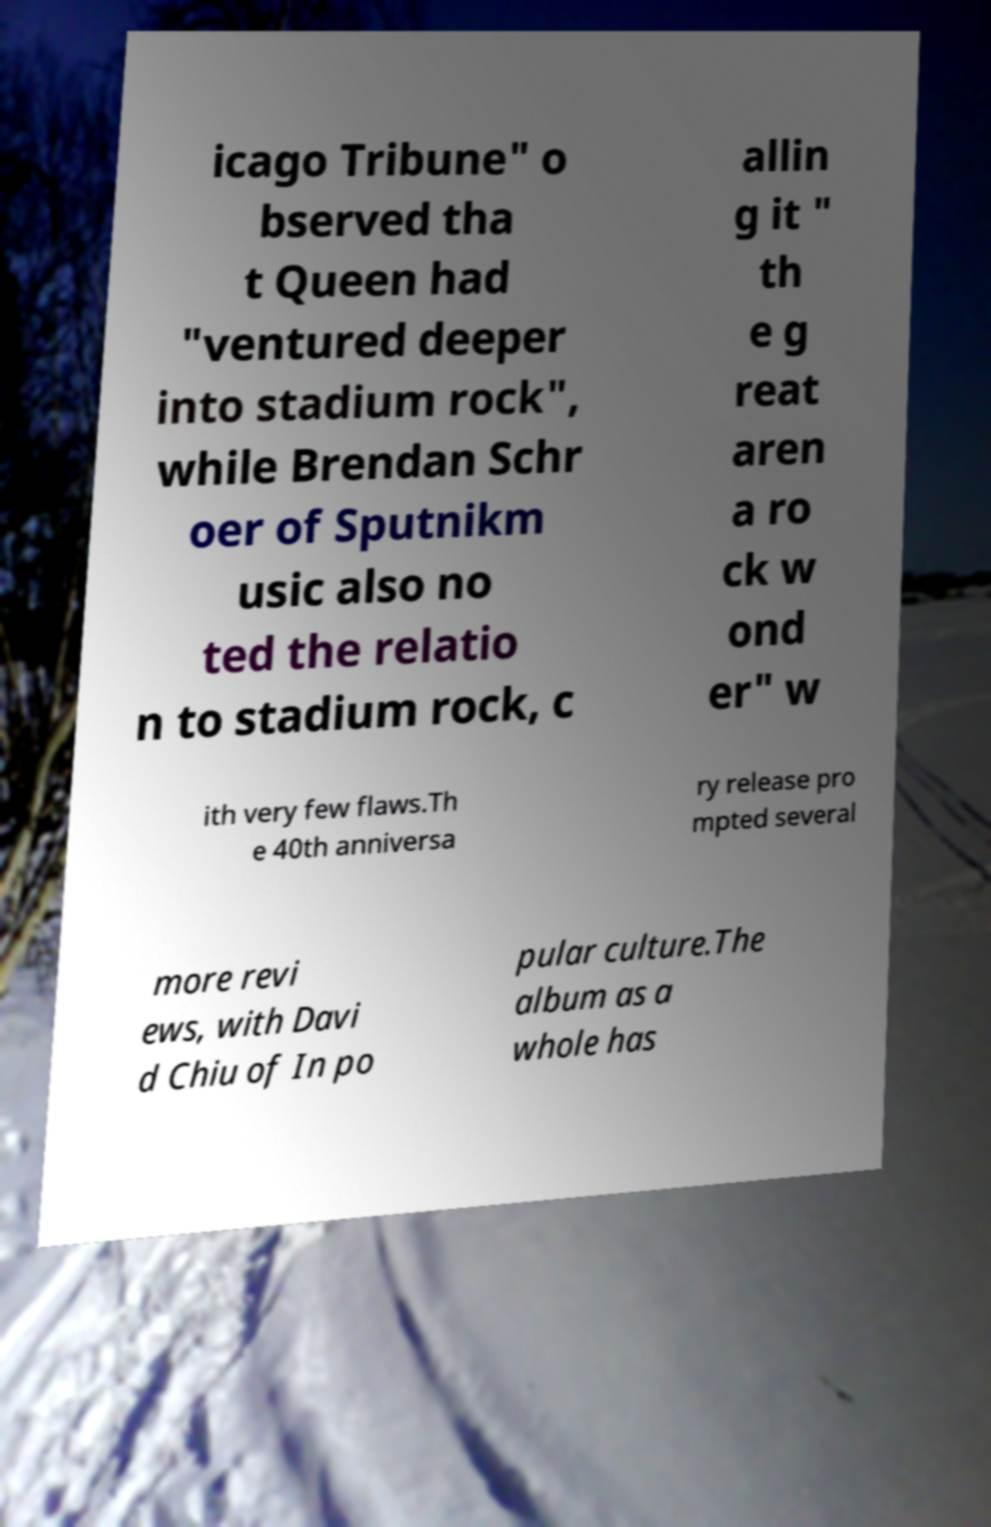Can you accurately transcribe the text from the provided image for me? icago Tribune" o bserved tha t Queen had "ventured deeper into stadium rock", while Brendan Schr oer of Sputnikm usic also no ted the relatio n to stadium rock, c allin g it " th e g reat aren a ro ck w ond er" w ith very few flaws.Th e 40th anniversa ry release pro mpted several more revi ews, with Davi d Chiu of In po pular culture.The album as a whole has 